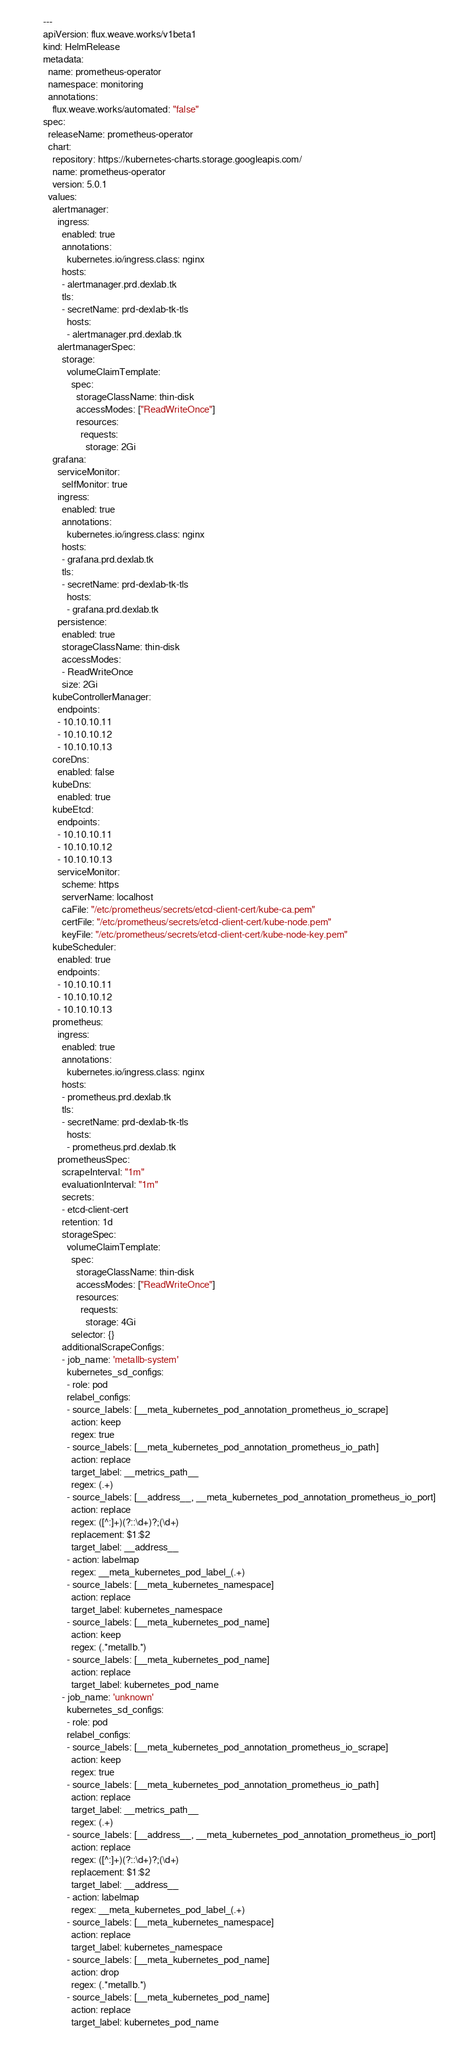<code> <loc_0><loc_0><loc_500><loc_500><_YAML_>---
apiVersion: flux.weave.works/v1beta1
kind: HelmRelease
metadata:
  name: prometheus-operator
  namespace: monitoring
  annotations:
    flux.weave.works/automated: "false"
spec:
  releaseName: prometheus-operator
  chart:
    repository: https://kubernetes-charts.storage.googleapis.com/
    name: prometheus-operator
    version: 5.0.1
  values:
    alertmanager:
      ingress:
        enabled: true
        annotations:
          kubernetes.io/ingress.class: nginx
        hosts:
        - alertmanager.prd.dexlab.tk
        tls:
        - secretName: prd-dexlab-tk-tls
          hosts:
          - alertmanager.prd.dexlab.tk
      alertmanagerSpec:
        storage:
          volumeClaimTemplate:
            spec:
              storageClassName: thin-disk
              accessModes: ["ReadWriteOnce"]
              resources:
                requests:
                  storage: 2Gi
    grafana:
      serviceMonitor:
        selfMonitor: true
      ingress:
        enabled: true
        annotations:
          kubernetes.io/ingress.class: nginx
        hosts:
        - grafana.prd.dexlab.tk
        tls:
        - secretName: prd-dexlab-tk-tls
          hosts:
          - grafana.prd.dexlab.tk
      persistence:
        enabled: true
        storageClassName: thin-disk
        accessModes:
        - ReadWriteOnce
        size: 2Gi
    kubeControllerManager:
      endpoints:
      - 10.10.10.11
      - 10.10.10.12
      - 10.10.10.13
    coreDns:
      enabled: false
    kubeDns:
      enabled: true
    kubeEtcd:
      endpoints:
      - 10.10.10.11
      - 10.10.10.12
      - 10.10.10.13
      serviceMonitor:
        scheme: https
        serverName: localhost
        caFile: "/etc/prometheus/secrets/etcd-client-cert/kube-ca.pem"
        certFile: "/etc/prometheus/secrets/etcd-client-cert/kube-node.pem"
        keyFile: "/etc/prometheus/secrets/etcd-client-cert/kube-node-key.pem"
    kubeScheduler:
      enabled: true
      endpoints:
      - 10.10.10.11
      - 10.10.10.12
      - 10.10.10.13
    prometheus:
      ingress:
        enabled: true
        annotations:
          kubernetes.io/ingress.class: nginx
        hosts:
        - prometheus.prd.dexlab.tk
        tls:
        - secretName: prd-dexlab-tk-tls
          hosts:
          - prometheus.prd.dexlab.tk
      prometheusSpec:
        scrapeInterval: "1m"
        evaluationInterval: "1m"
        secrets:
        - etcd-client-cert
        retention: 1d
        storageSpec:
          volumeClaimTemplate:
            spec:
              storageClassName: thin-disk
              accessModes: ["ReadWriteOnce"]
              resources:
                requests:
                  storage: 4Gi
            selector: {}
        additionalScrapeConfigs:
        - job_name: 'metallb-system'
          kubernetes_sd_configs:
          - role: pod
          relabel_configs:
          - source_labels: [__meta_kubernetes_pod_annotation_prometheus_io_scrape]
            action: keep
            regex: true
          - source_labels: [__meta_kubernetes_pod_annotation_prometheus_io_path]
            action: replace
            target_label: __metrics_path__
            regex: (.+)
          - source_labels: [__address__, __meta_kubernetes_pod_annotation_prometheus_io_port]
            action: replace
            regex: ([^:]+)(?::\d+)?;(\d+)
            replacement: $1:$2
            target_label: __address__
          - action: labelmap
            regex: __meta_kubernetes_pod_label_(.+)
          - source_labels: [__meta_kubernetes_namespace]
            action: replace
            target_label: kubernetes_namespace
          - source_labels: [__meta_kubernetes_pod_name]
            action: keep
            regex: (.*metallb.*)
          - source_labels: [__meta_kubernetes_pod_name]
            action: replace
            target_label: kubernetes_pod_name
        - job_name: 'unknown'
          kubernetes_sd_configs:
          - role: pod
          relabel_configs:
          - source_labels: [__meta_kubernetes_pod_annotation_prometheus_io_scrape]
            action: keep
            regex: true
          - source_labels: [__meta_kubernetes_pod_annotation_prometheus_io_path]
            action: replace
            target_label: __metrics_path__
            regex: (.+)
          - source_labels: [__address__, __meta_kubernetes_pod_annotation_prometheus_io_port]
            action: replace
            regex: ([^:]+)(?::\d+)?;(\d+)
            replacement: $1:$2
            target_label: __address__
          - action: labelmap
            regex: __meta_kubernetes_pod_label_(.+)
          - source_labels: [__meta_kubernetes_namespace]
            action: replace
            target_label: kubernetes_namespace
          - source_labels: [__meta_kubernetes_pod_name]
            action: drop
            regex: (.*metallb.*)
          - source_labels: [__meta_kubernetes_pod_name]
            action: replace
            target_label: kubernetes_pod_name
</code> 